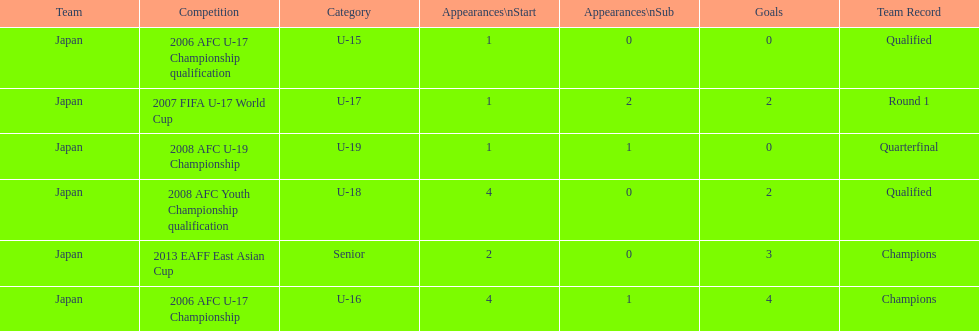Did japan have more starting appearances in the 2013 eaff east asian cup or 2007 fifa u-17 world cup? 2013 EAFF East Asian Cup. 